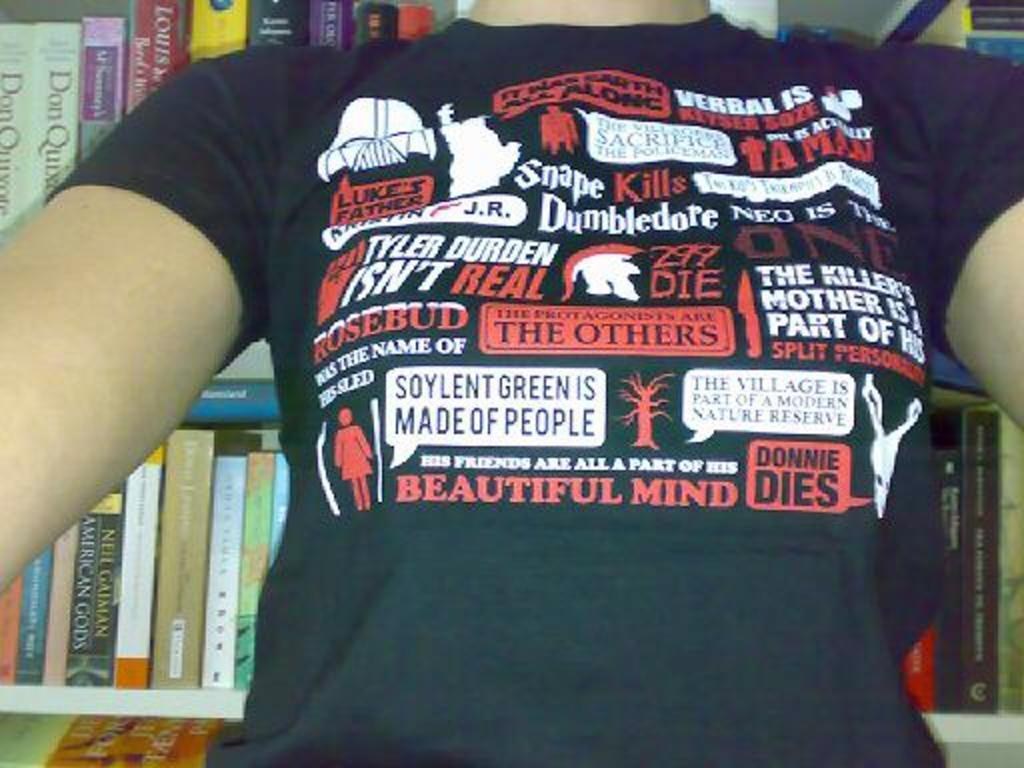<image>
Offer a succinct explanation of the picture presented. A shirt with captions including Donnie Dies, Rosebud, and Snape Kills. 